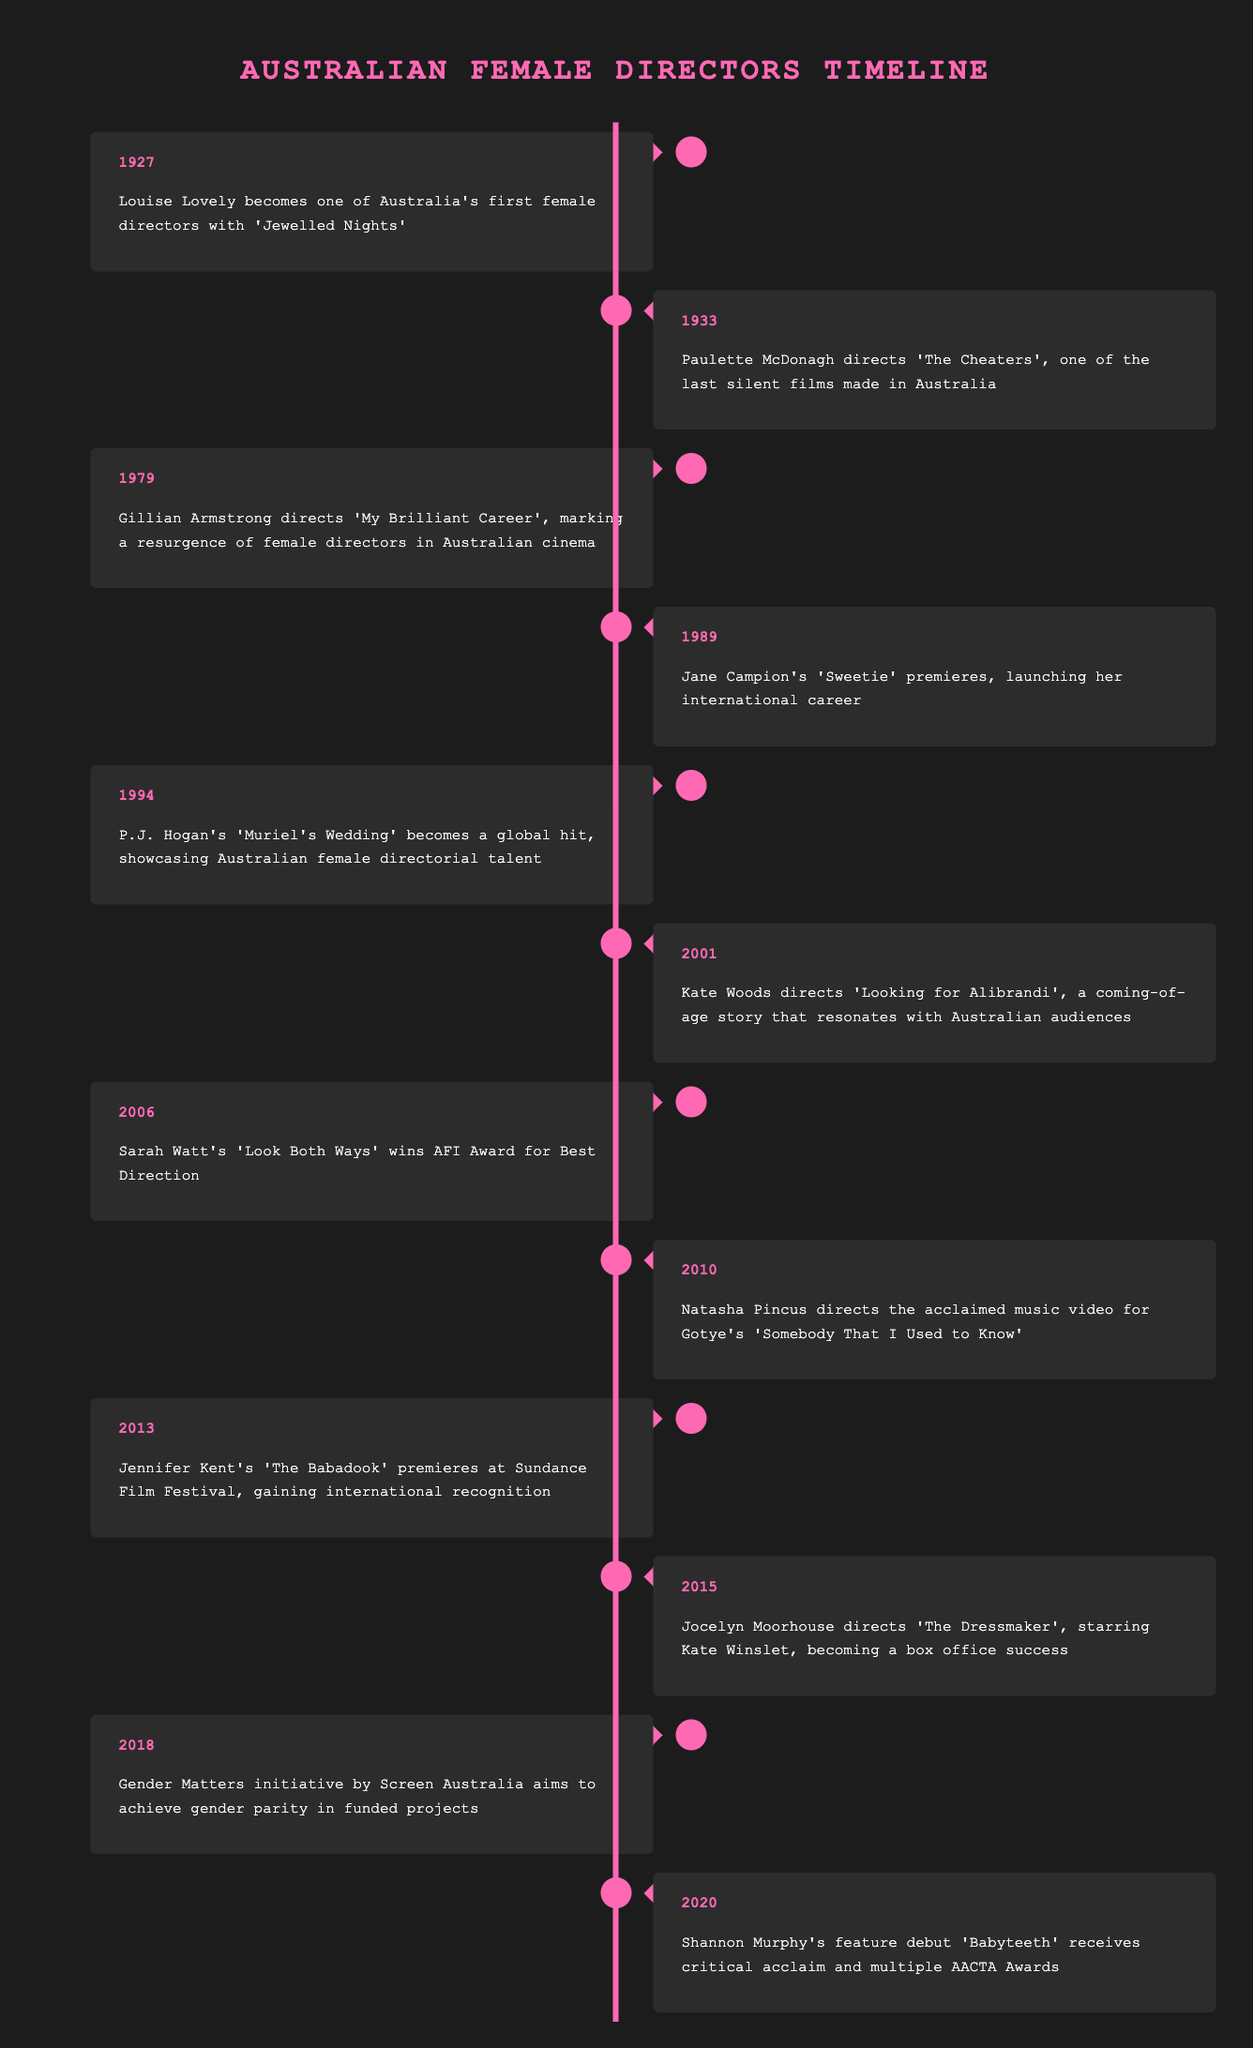What year did Louise Lovely become a director? Louise Lovely is noted as one of Australia's first female directors in the timeline for the year 1927.
Answer: 1927 Which film did Gillian Armstrong direct in 1979? According to the timeline, Gillian Armstrong directed 'My Brilliant Career' in 1979.
Answer: My Brilliant Career Was 'The Babadook' directed by a female director? The timeline states that 'The Babadook', directed by Jennifer Kent, premiered in 2013, confirming it was directed by a female.
Answer: Yes How many years are there between the first female director and Natasha Pincus's music video? Louise Lovely became a director in 1927, and Natasha Pincus directed her music video in 2010. The difference is 2010 - 1927 = 83 years.
Answer: 83 years Which female director had a film that premiered at Sundance Film Festival? The timeline indicates that Jennifer Kent's 'The Babadook' premiered at Sundance Film Festival in 2013, confirming her role as a female director for that event.
Answer: Jennifer Kent 